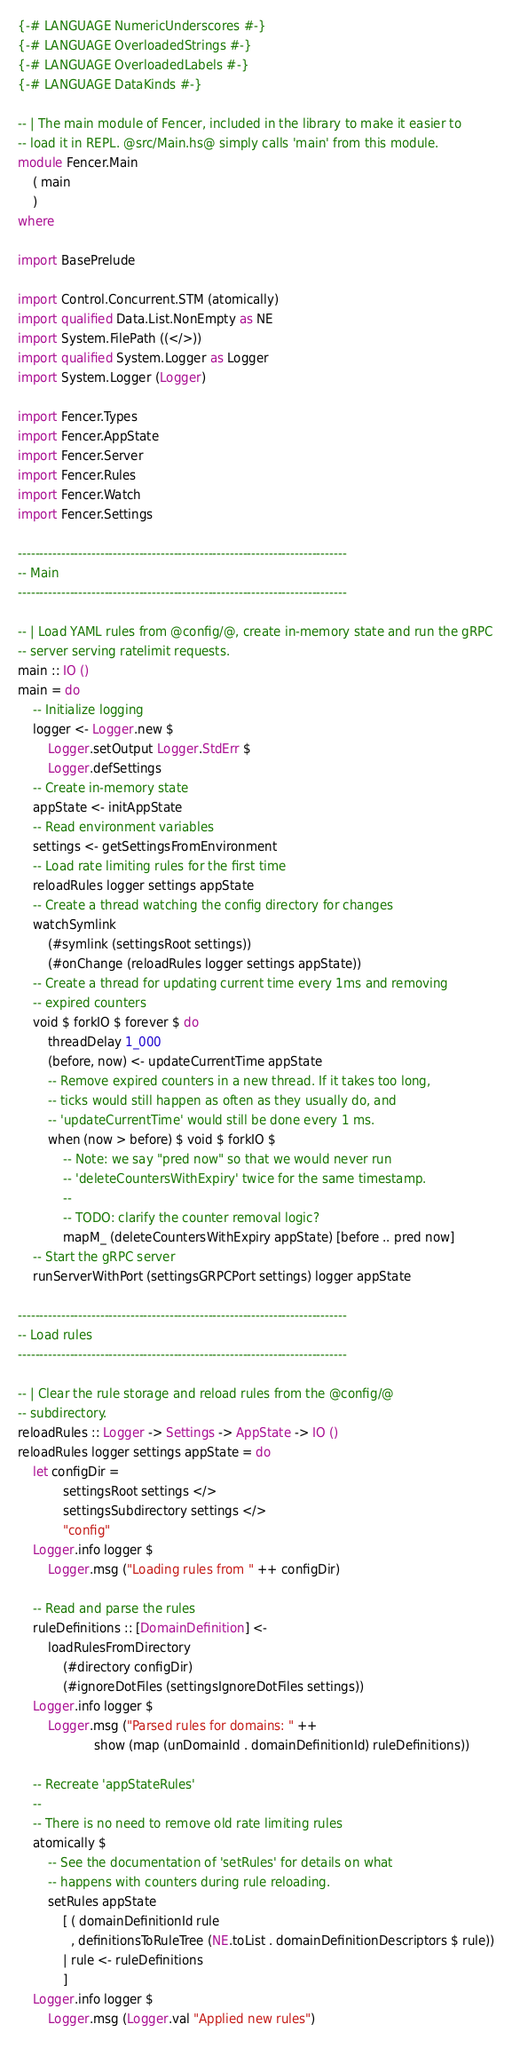Convert code to text. <code><loc_0><loc_0><loc_500><loc_500><_Haskell_>{-# LANGUAGE NumericUnderscores #-}
{-# LANGUAGE OverloadedStrings #-}
{-# LANGUAGE OverloadedLabels #-}
{-# LANGUAGE DataKinds #-}

-- | The main module of Fencer, included in the library to make it easier to
-- load it in REPL. @src/Main.hs@ simply calls 'main' from this module.
module Fencer.Main
    ( main
    )
where

import BasePrelude

import Control.Concurrent.STM (atomically)
import qualified Data.List.NonEmpty as NE
import System.FilePath ((</>))
import qualified System.Logger as Logger
import System.Logger (Logger)

import Fencer.Types
import Fencer.AppState
import Fencer.Server
import Fencer.Rules
import Fencer.Watch
import Fencer.Settings

----------------------------------------------------------------------------
-- Main
----------------------------------------------------------------------------

-- | Load YAML rules from @config/@, create in-memory state and run the gRPC
-- server serving ratelimit requests.
main :: IO ()
main = do
    -- Initialize logging
    logger <- Logger.new $
        Logger.setOutput Logger.StdErr $
        Logger.defSettings
    -- Create in-memory state
    appState <- initAppState
    -- Read environment variables
    settings <- getSettingsFromEnvironment
    -- Load rate limiting rules for the first time
    reloadRules logger settings appState
    -- Create a thread watching the config directory for changes
    watchSymlink
        (#symlink (settingsRoot settings))
        (#onChange (reloadRules logger settings appState))
    -- Create a thread for updating current time every 1ms and removing
    -- expired counters
    void $ forkIO $ forever $ do
        threadDelay 1_000
        (before, now) <- updateCurrentTime appState
        -- Remove expired counters in a new thread. If it takes too long,
        -- ticks would still happen as often as they usually do, and
        -- 'updateCurrentTime' would still be done every 1 ms.
        when (now > before) $ void $ forkIO $
            -- Note: we say "pred now" so that we would never run
            -- 'deleteCountersWithExpiry' twice for the same timestamp.
            --
            -- TODO: clarify the counter removal logic?
            mapM_ (deleteCountersWithExpiry appState) [before .. pred now]
    -- Start the gRPC server
    runServerWithPort (settingsGRPCPort settings) logger appState

----------------------------------------------------------------------------
-- Load rules
----------------------------------------------------------------------------

-- | Clear the rule storage and reload rules from the @config/@
-- subdirectory.
reloadRules :: Logger -> Settings -> AppState -> IO ()
reloadRules logger settings appState = do
    let configDir =
            settingsRoot settings </>
            settingsSubdirectory settings </>
            "config"
    Logger.info logger $
        Logger.msg ("Loading rules from " ++ configDir)

    -- Read and parse the rules
    ruleDefinitions :: [DomainDefinition] <-
        loadRulesFromDirectory
            (#directory configDir)
            (#ignoreDotFiles (settingsIgnoreDotFiles settings))
    Logger.info logger $
        Logger.msg ("Parsed rules for domains: " ++
                    show (map (unDomainId . domainDefinitionId) ruleDefinitions))

    -- Recreate 'appStateRules'
    --
    -- There is no need to remove old rate limiting rules
    atomically $
        -- See the documentation of 'setRules' for details on what
        -- happens with counters during rule reloading.
        setRules appState
            [ ( domainDefinitionId rule
              , definitionsToRuleTree (NE.toList . domainDefinitionDescriptors $ rule))
            | rule <- ruleDefinitions
            ]
    Logger.info logger $
        Logger.msg (Logger.val "Applied new rules")
</code> 